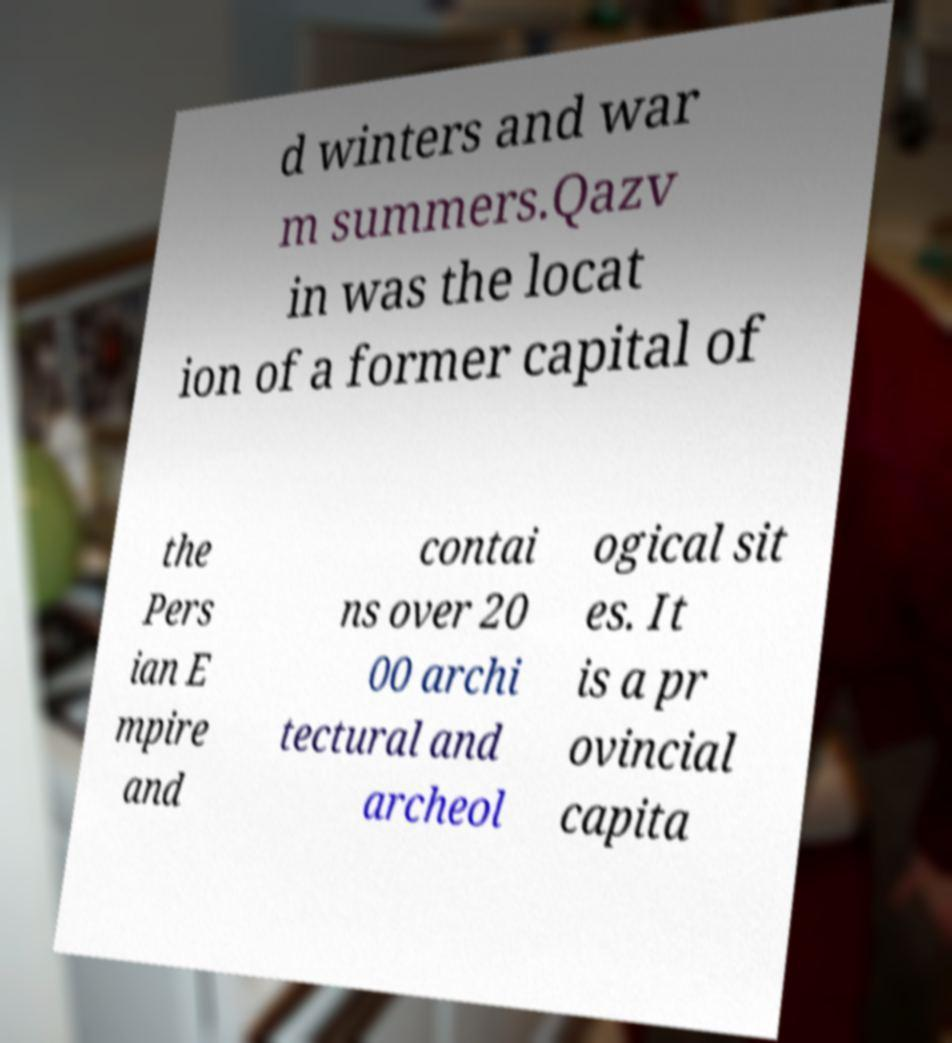I need the written content from this picture converted into text. Can you do that? d winters and war m summers.Qazv in was the locat ion of a former capital of the Pers ian E mpire and contai ns over 20 00 archi tectural and archeol ogical sit es. It is a pr ovincial capita 